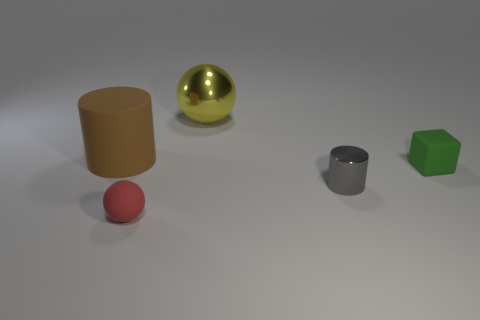Add 5 matte cylinders. How many objects exist? 10 Subtract all cubes. How many objects are left? 4 Subtract all tiny purple metal cubes. Subtract all large brown rubber cylinders. How many objects are left? 4 Add 2 gray things. How many gray things are left? 3 Add 4 tiny yellow rubber blocks. How many tiny yellow rubber blocks exist? 4 Subtract 0 red cylinders. How many objects are left? 5 